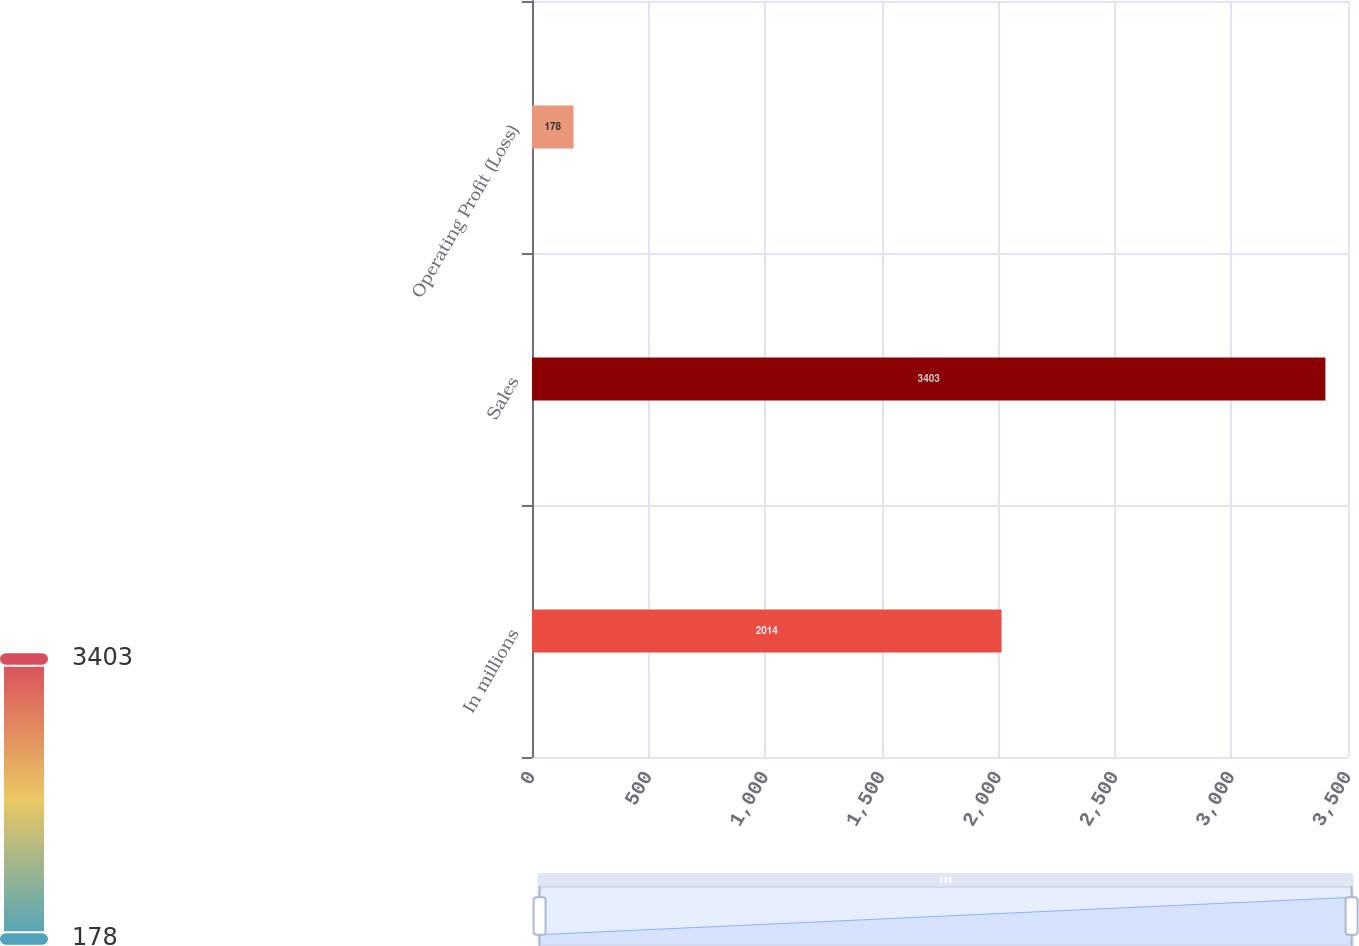<chart> <loc_0><loc_0><loc_500><loc_500><bar_chart><fcel>In millions<fcel>Sales<fcel>Operating Profit (Loss)<nl><fcel>2014<fcel>3403<fcel>178<nl></chart> 